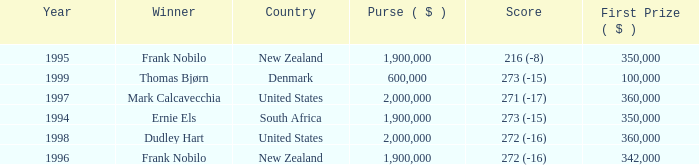What was the total purse in the years after 1996 with a score of 272 (-16) when frank nobilo won? None. Parse the full table. {'header': ['Year', 'Winner', 'Country', 'Purse ( $ )', 'Score', 'First Prize ( $ )'], 'rows': [['1995', 'Frank Nobilo', 'New Zealand', '1,900,000', '216 (-8)', '350,000'], ['1999', 'Thomas Bjørn', 'Denmark', '600,000', '273 (-15)', '100,000'], ['1997', 'Mark Calcavecchia', 'United States', '2,000,000', '271 (-17)', '360,000'], ['1994', 'Ernie Els', 'South Africa', '1,900,000', '273 (-15)', '350,000'], ['1998', 'Dudley Hart', 'United States', '2,000,000', '272 (-16)', '360,000'], ['1996', 'Frank Nobilo', 'New Zealand', '1,900,000', '272 (-16)', '342,000']]} 